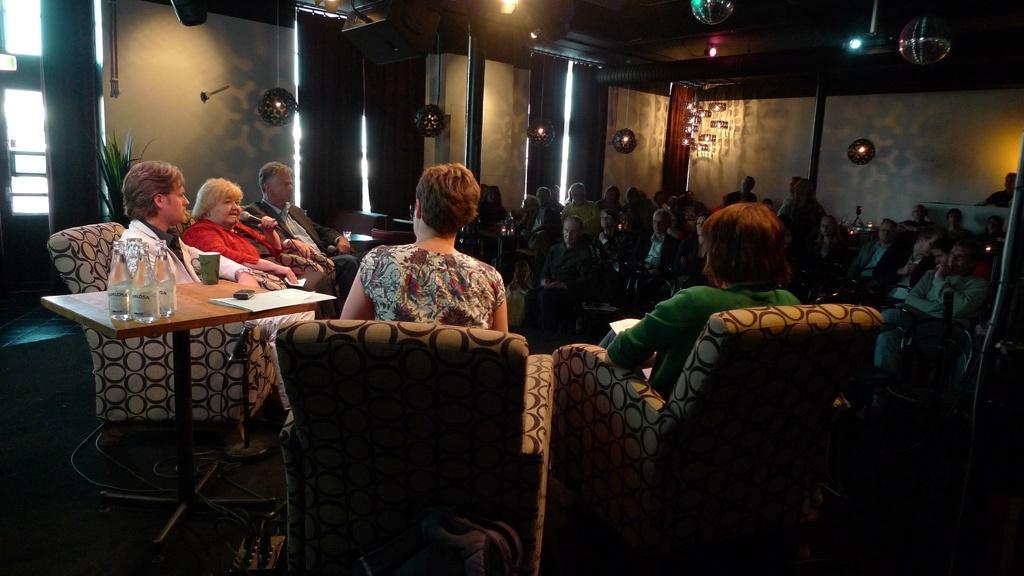Could you give a brief overview of what you see in this image? Group of people are sitting on chairs. In between of this two persons there is a table, on this table there bottles, papers, mobile and cup. On top there are lights. Beside this window there is a plant. 